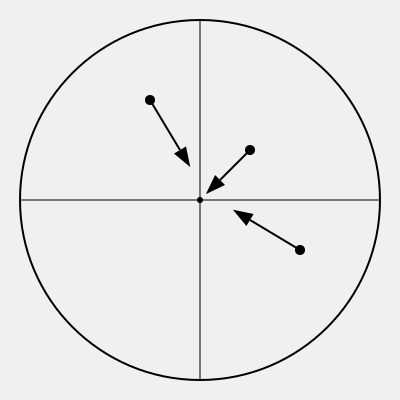In the given vector diagram representing cricket fielding positions and movement patterns, calculate the total displacement of all three fielders combined. Assume that the radius of the cricket field is 70 meters and that the vectors are drawn to scale. To solve this problem, we need to follow these steps:

1. Determine the scale of the diagram:
   The radius of the circle is 180 pixels, which represents 70 meters.
   Scale: 70 meters / 180 pixels = 0.3889 meters/pixel

2. Measure the displacement vectors for each fielder:
   Red fielder: approximately 50 pixels
   Blue fielder: approximately 45 pixels
   Green fielder: approximately 60 pixels

3. Convert pixel measurements to meters:
   Red fielder: 50 * 0.3889 = 19.445 meters
   Blue fielder: 45 * 0.3889 = 17.5005 meters
   Green fielder: 60 * 0.3889 = 23.334 meters

4. Calculate the total displacement:
   Total displacement = 19.445 + 17.5005 + 23.334 = 60.2795 meters

5. Round to a reasonable number of significant figures:
   60.3 meters (3 significant figures)
Answer: 60.3 meters 